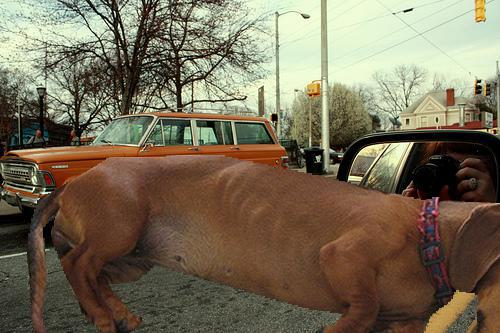How many unicorns would there be in the image if one additional unicorn was added in the scene? As there are no unicorns currently present in the image, adding one would result in a single unicorn being in the scene. 